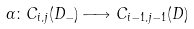<formula> <loc_0><loc_0><loc_500><loc_500>\alpha \colon C _ { i , j } ( D _ { - } ) \longrightarrow C _ { i - 1 , j - 1 } ( D )</formula> 